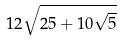<formula> <loc_0><loc_0><loc_500><loc_500>1 2 \sqrt { 2 5 + 1 0 \sqrt { 5 } }</formula> 